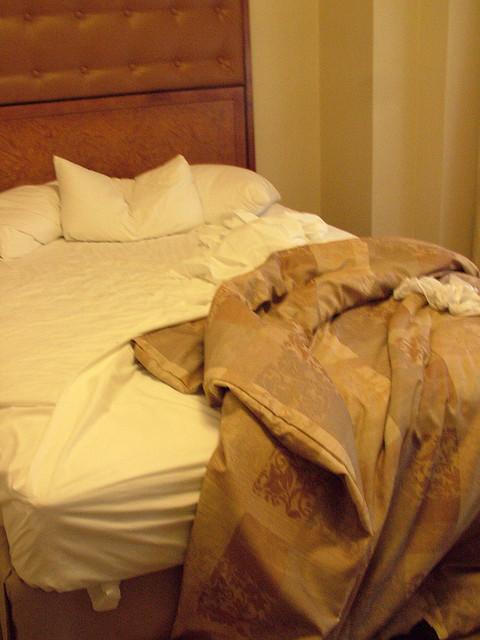Is there a pillow on the bed?
Keep it brief. Yes. Does this bed need to be made?
Quick response, please. Yes. How many pillows are on this bed?
Short answer required. 3. Is the comforter a solid color?
Answer briefly. No. 